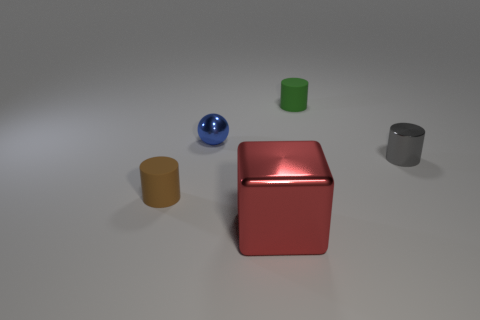Add 1 tiny spheres. How many objects exist? 6 Subtract all balls. How many objects are left? 4 Add 5 yellow blocks. How many yellow blocks exist? 5 Subtract 1 blue balls. How many objects are left? 4 Subtract all shiny blocks. Subtract all small blue spheres. How many objects are left? 3 Add 5 blue shiny objects. How many blue shiny objects are left? 6 